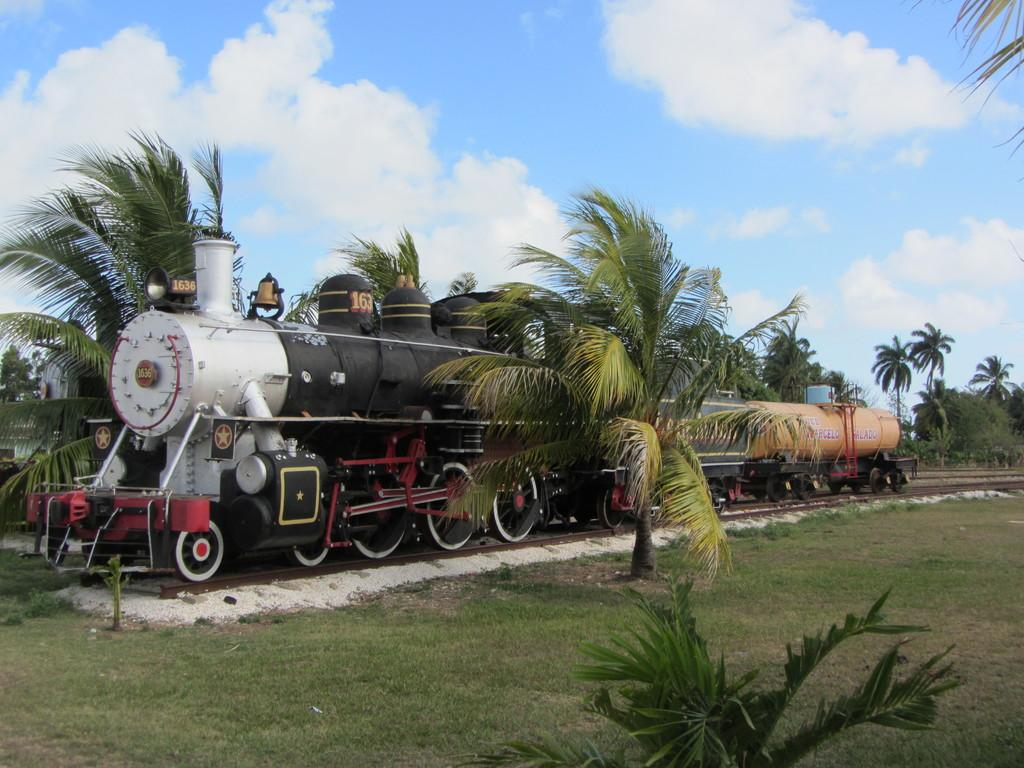What is the main subject in the center of the image? There is a train in the center of the image. What type of vegetation can be seen in the image? There are trees and plants in the image. What is present at the bottom of the image? There is grass and plants at the bottom of the image. What is visible in the background of the image? There are trees in the background of the image. What is visible at the top of the image? The sky is visible at the top of the image. What type of degree is being awarded to the train in the image? There is no indication in the image that a degree is being awarded to the train, as trains do not receive degrees. 